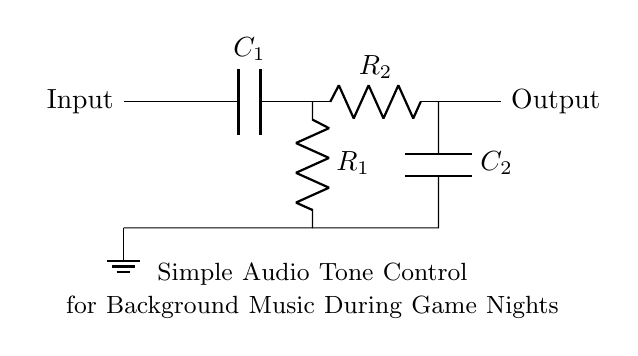What type of filters are used in this circuit? The circuit contains two types of filters: a high-pass filter formed by the capacitor and resistor at the top, and a low-pass filter formed by the resistor and capacitor at the bottom.
Answer: high-pass and low-pass How many resistors are present in the circuit? The circuit includes two resistors labeled as R1 and R2, located in different sections of the diagram.
Answer: two What is the purpose of the capacitors in this circuit? The capacitors in this circuit are used to block DC signals and allow AC signals to pass, playing a crucial role in forming the high-pass and low-pass filters for tone control.
Answer: tone control Which component is connected to ground? The circuit shows that the bottom connection of the high-pass filter goes to ground, indicating the reference point for the circuit.
Answer: R1 What is the function of the output in this circuit? The output is where the processed audio signal is taken from after going through the filtering process, which is essential for controlling tone in the audio system.
Answer: processed audio signal What are the labeled values for the components? The diagram does not provide specific numerical values for the components but shows them labeled generically as R1, R2, C1, and C2.
Answer: R1, R2, C1, C2 Which component influences the high frequencies in this circuit? The capacitor C1 is responsible for influencing the high frequencies by allowing them to pass through while blocking lower frequencies in the high-pass filter configuration.
Answer: C1 